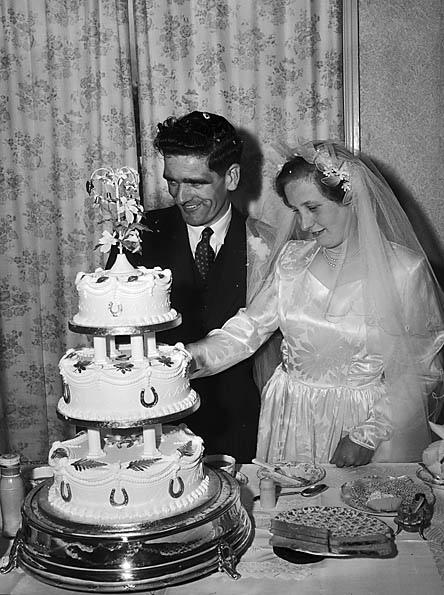How many tiers is this wedding cake?
Answer briefly. 3. What are the people doing?
Quick response, please. Cutting cake. Is this a recent photo?
Keep it brief. No. Is the bride young?
Quick response, please. Yes. 